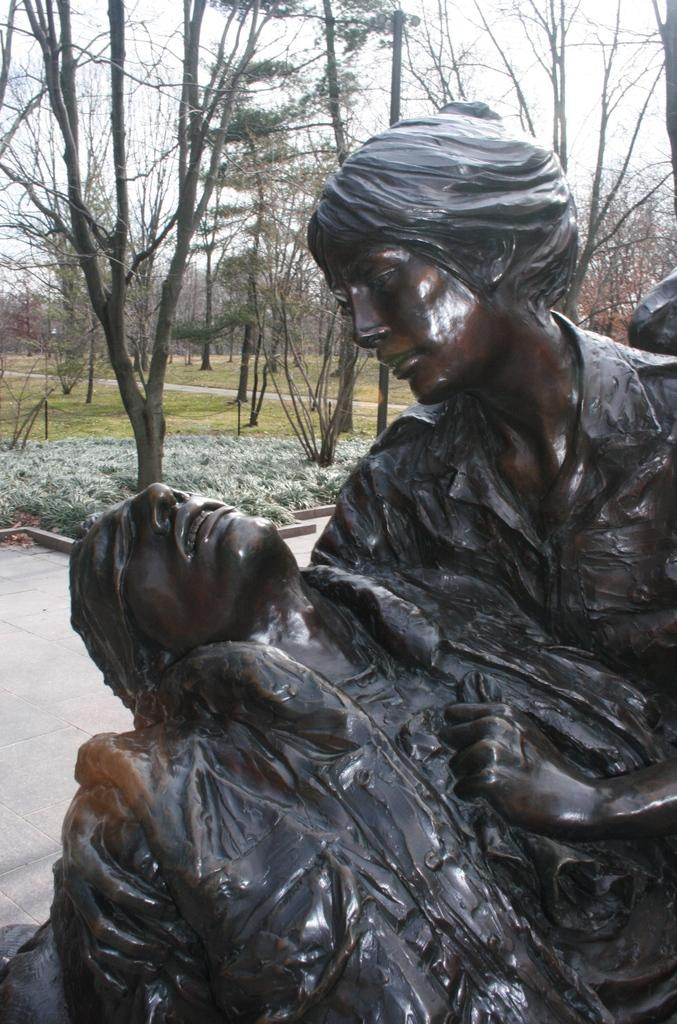Where was the image taken? The image was clicked outside. What can be seen in the foreground of the image? There are sculptures of two persons in the foreground. What type of vegetation is visible in the background? There are trees in the background. What else can be seen in the background of the image? There is grass, trees, and other objects visible in the background. What is visible in the sky in the image? The sky is visible in the background of the image. Can you see any credit cards in the image? There are no credit cards visible in the image. Is there an airplane flying in the sky in the image? There is no airplane visible in the sky in the image. 